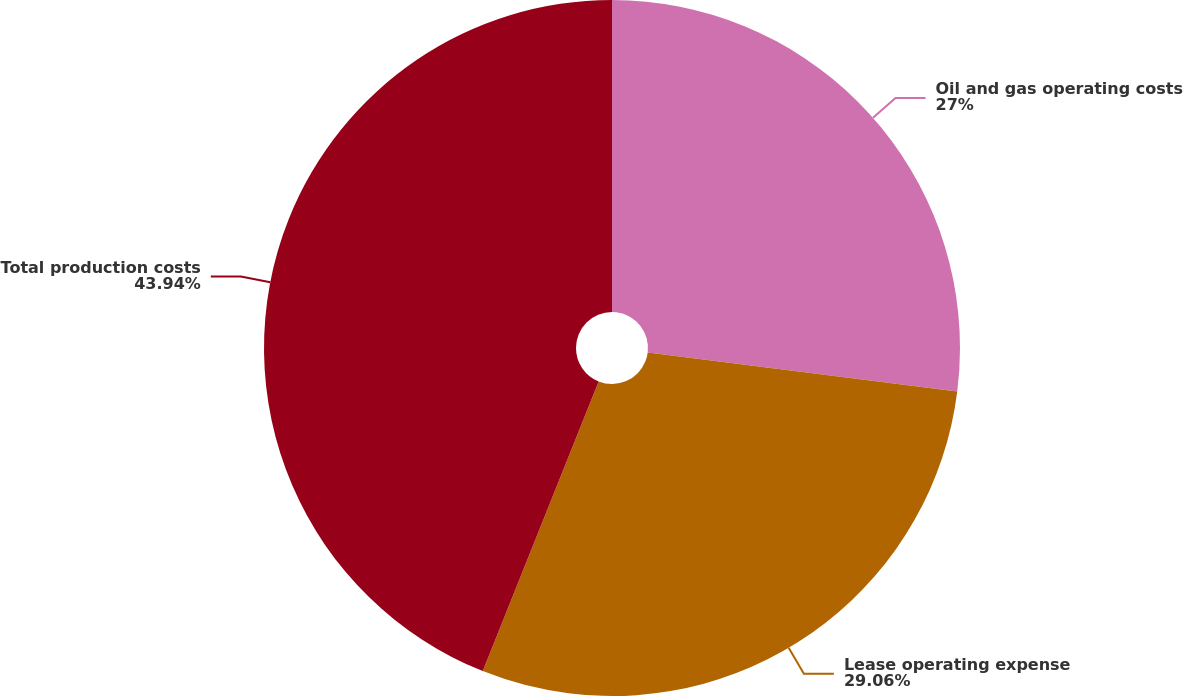<chart> <loc_0><loc_0><loc_500><loc_500><pie_chart><fcel>Oil and gas operating costs<fcel>Lease operating expense<fcel>Total production costs<nl><fcel>27.0%<fcel>29.06%<fcel>43.95%<nl></chart> 